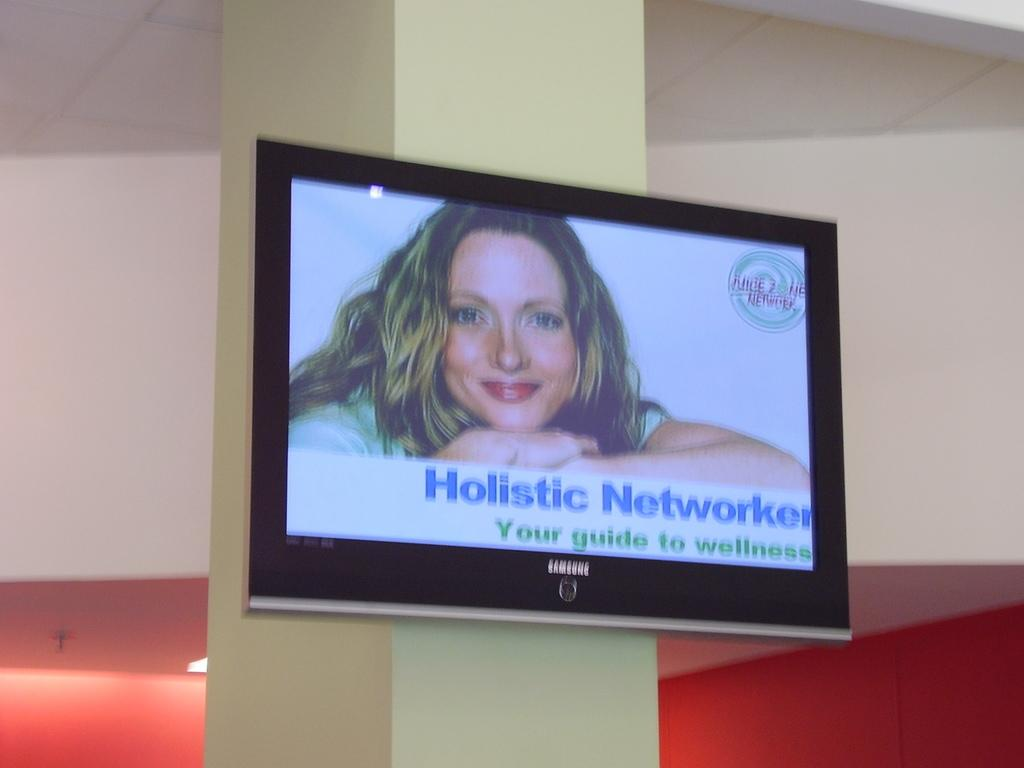<image>
Present a compact description of the photo's key features. A screen with a holistic advertisement on it 